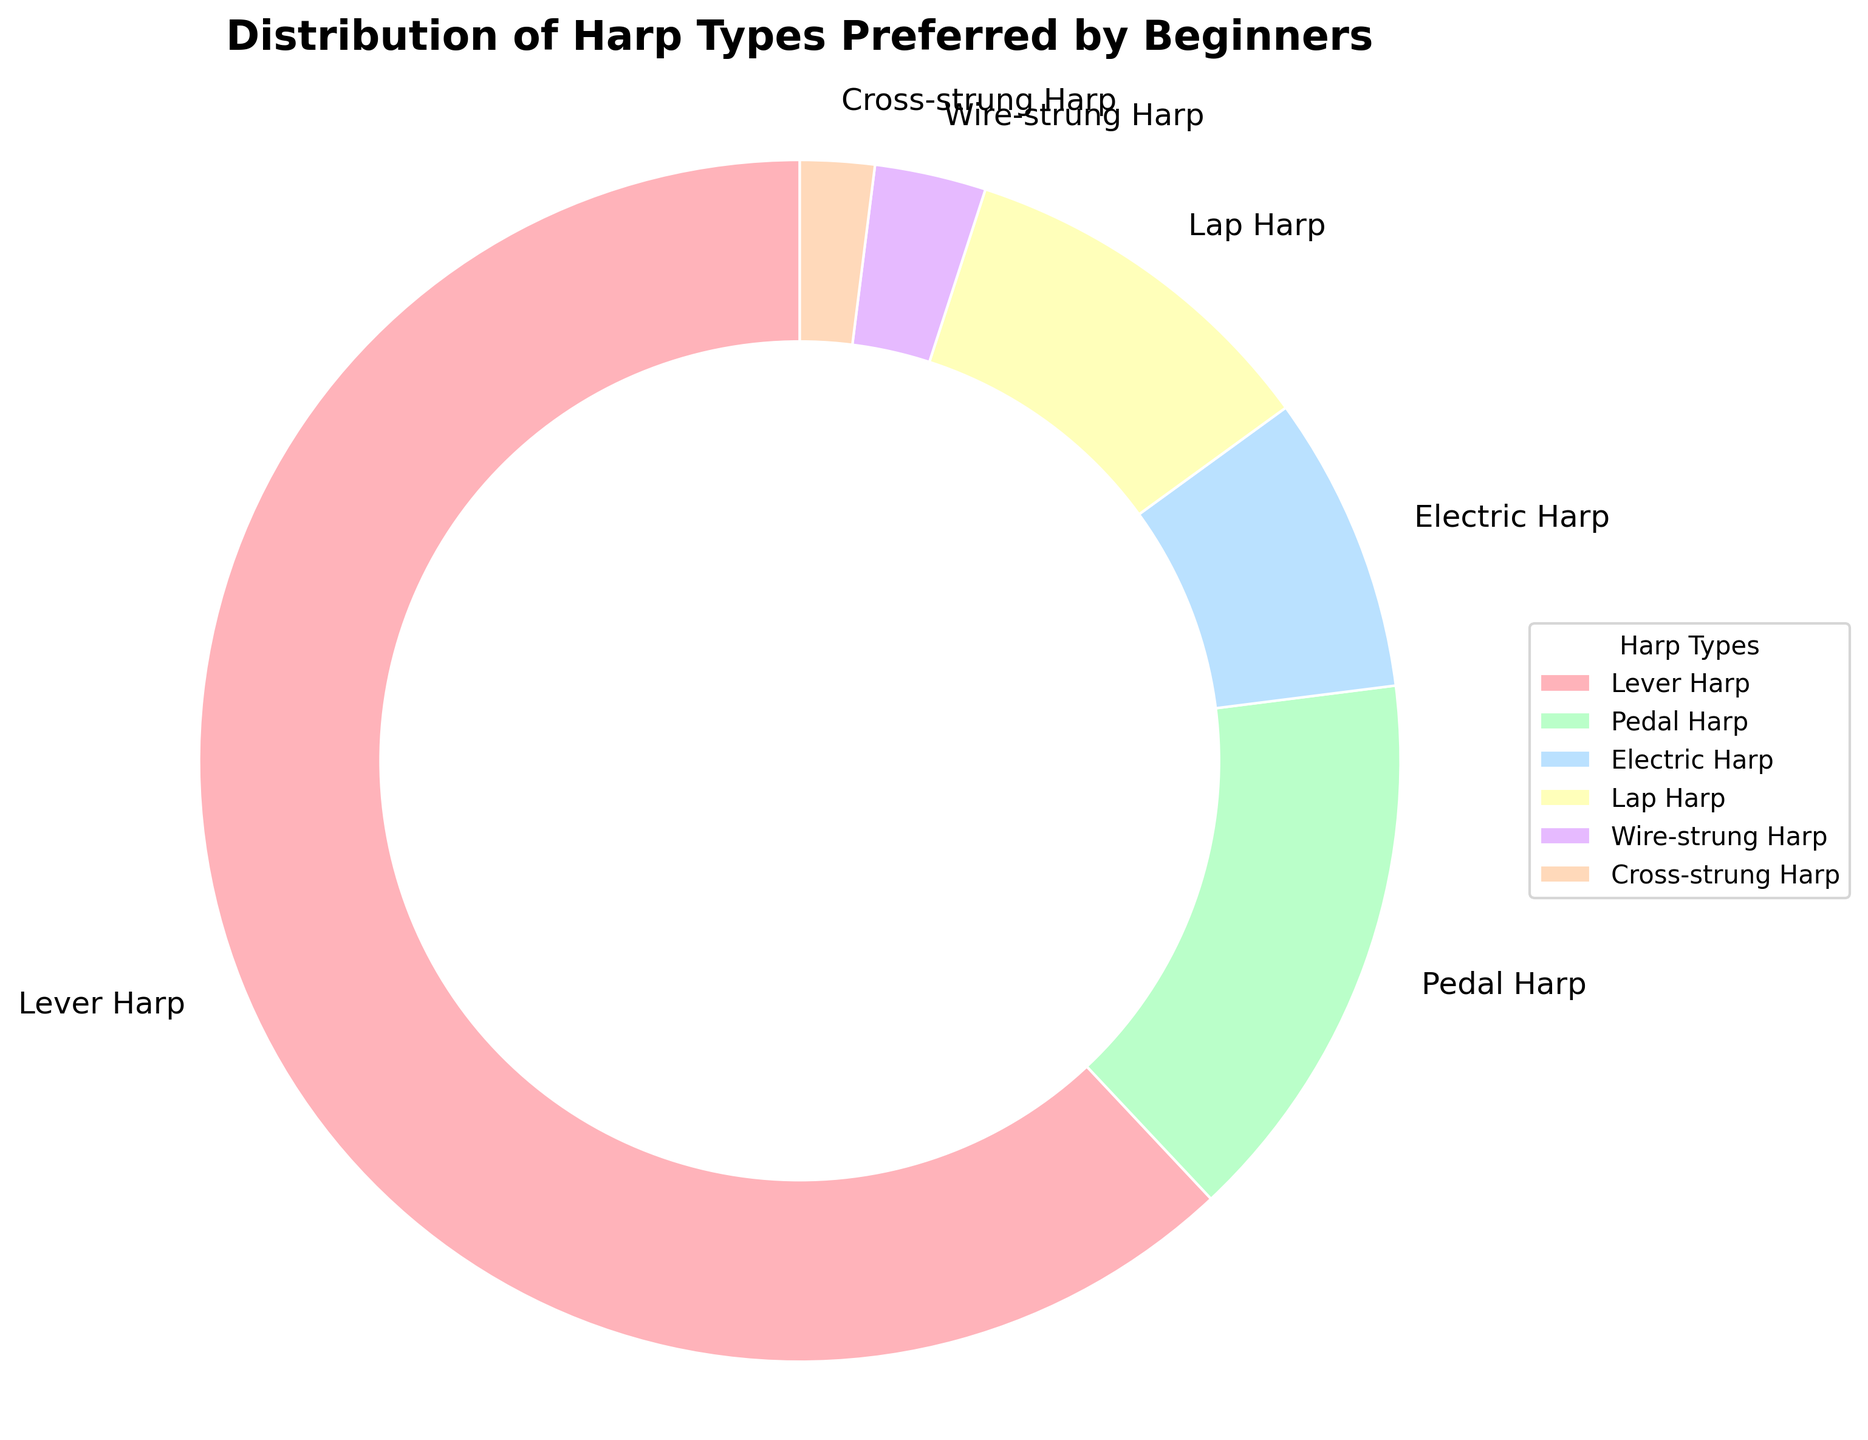What percent of beginners prefer lever harps? The wedge corresponding to lever harps in the pie chart is labeled with the percentage directly.
Answer: 62% What is the difference in percentage between lever harps and pedal harps? Lever harps have a percentage of 62% and pedal harps have 15%. Subtract the two: 62% - 15% = 47%.
Answer: 47% Which harp type is preferred by the least number of beginners? The smallest wedge in the pie chart corresponds to the cross-strung harp, which is labeled with 2%.
Answer: Cross-strung Harp Which two types of harps have a combined preference percentage of 18%? Wire-strung harps have 3% and pedal harps have 15%. Adding these together gives 3% + 15% = 18%.
Answer: Wire-strung Harp and Pedal Harp What is the total percentage of beginners who prefer either lap harps or electric harps? The lap harps have a preference of 10% and electric harps have 8%. Summing these, 10% + 8% = 18%.
Answer: 18% How many more percent beginners prefer lever harps compared to lap harps? Lever harps are preferred by 62% and lap harps by 10%. The difference is 62% - 10% = 52%.
Answer: 52% Which harp type occupies the largest segment in the pie chart? By visual inspection of the segments, the largest segment corresponds to the lever harp.
Answer: Lever Harp What percentage of beginners prefer wire-strung, cross-strung, and lap harps combined? Add the percentages of the wire-strung harp (3%), cross-strung harp (2%), and lap harp (10%) together: 3% + 2% + 10% = 15%.
Answer: 15% Is the percentage of beginners who prefer electric harps greater than those who prefer wire-strung harps? Compare the segments: electric harps are 8%, and wire-strung harps are 3%.
Answer: Yes What is the average percentage of beginners who prefer lever, pedal, and electric harps? Sum their percentages (62% + 15% + 8%) and divide by 3: (62 + 15 + 8) / 3 = 85 / 3 ≈ 28.33%.
Answer: 28.33% 